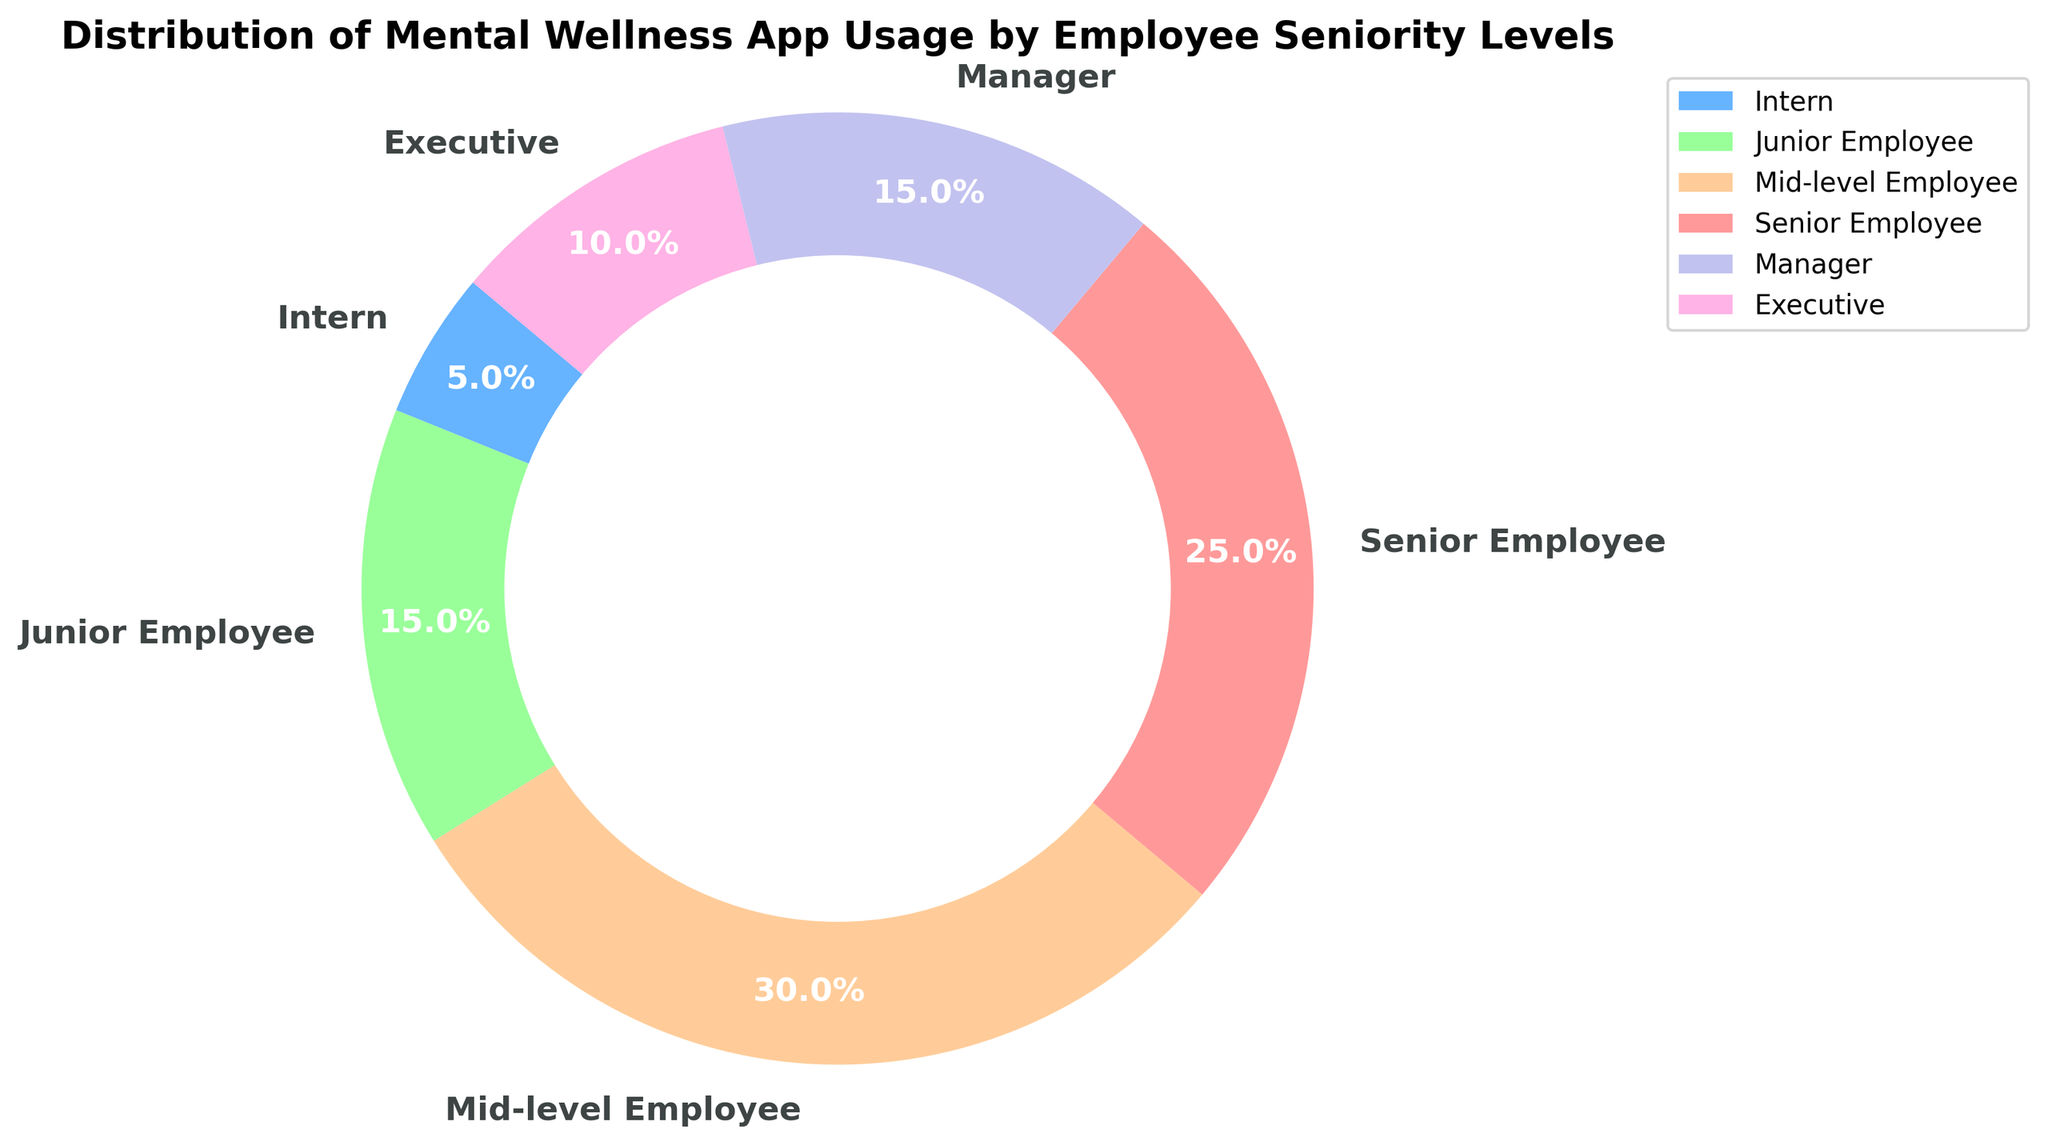What percentage of mental wellness app usage is attributed to mid-level employees? Look at the slice labeled "Mid-level Employee" on the ring chart and read the percentage displayed.
Answer: 30% Which seniority level has the lowest usage percentage of the mental wellness app? Compare each slice's percentage, and identify the one with the smallest value.
Answer: Intern How does the usage percentage of junior employees compare to that of managers? Find the percentages for both Junior Employees (15%) and Managers (15%), and recognize that they are the same.
Answer: Equal What is the combined usage percentage of the wellness app for interns and executives? Add the percentage values for Interns (5%) and Executives (10%).
Answer: 15% Which seniority levels have a usage percentage greater than executives? Compare the 10% usage by Executives with the other values: Mid-level (30%), Senior Employee (25%), Junior Employee (15%), and Manager (15%) all are greater.
Answer: Mid-level Employee, Senior Employee, Junior Employee, Manager What is the difference in usage percentage between senior employees and executives? Subtract the usage percentage of Executives (10%) from that of Senior Employees (25%).
Answer: 15% What is the average usage percentage for junior employees, managers, and mid-level employees? Calculate the average of the usage percentages for Junior Employees (15%), Managers (15%), and Mid-level Employees (30%): (15 + 15 + 30) / 3 = 20.
Answer: 20% Which seniority level has the most usage of the mental wellness app? Identify the slice with the highest percentage, labeled as "Mid-level Employee" with 30%.
Answer: Mid-level Employee What color represents the section for junior employees? Look at the color of the slice labeled "Junior Employee" on the chart.
Answer: Green 